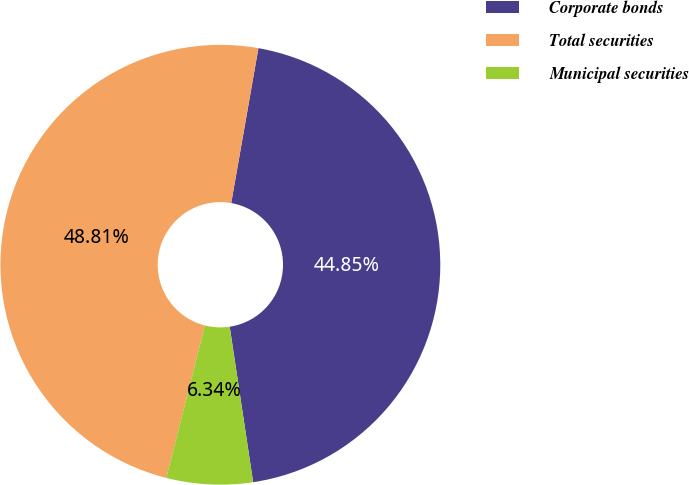Convert chart to OTSL. <chart><loc_0><loc_0><loc_500><loc_500><pie_chart><fcel>Corporate bonds<fcel>Total securities<fcel>Municipal securities<nl><fcel>44.85%<fcel>48.81%<fcel>6.34%<nl></chart> 